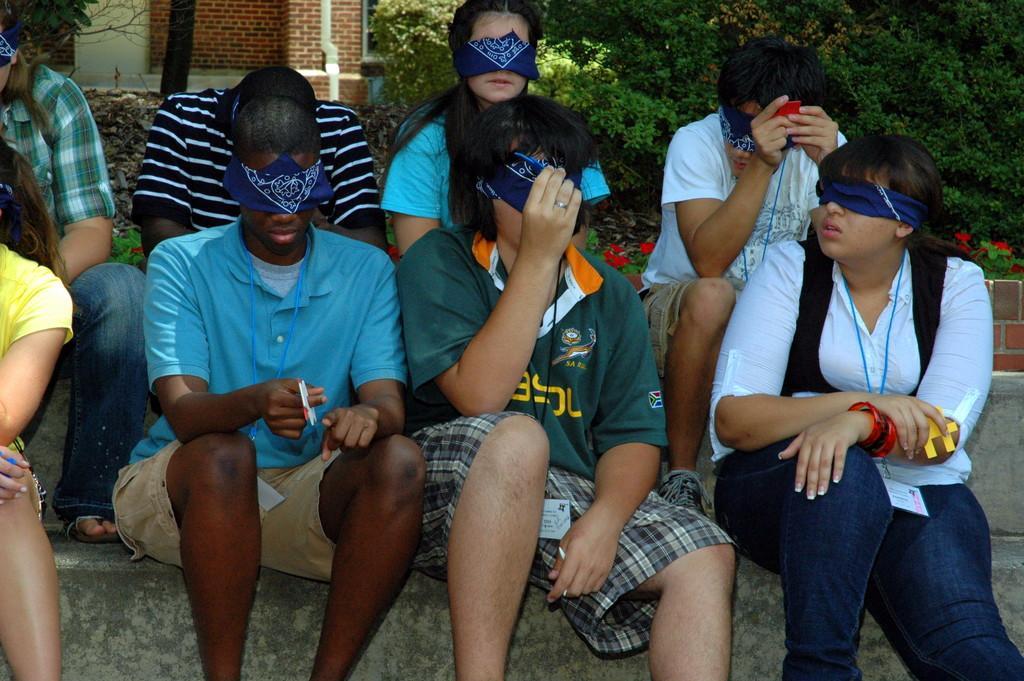Describe this image in one or two sentences. In this image I can see group of people sitting. In front the person is wearing green color shirt, background I can see few flowers in red color, plants in green color and the wall is in white and brown color. 